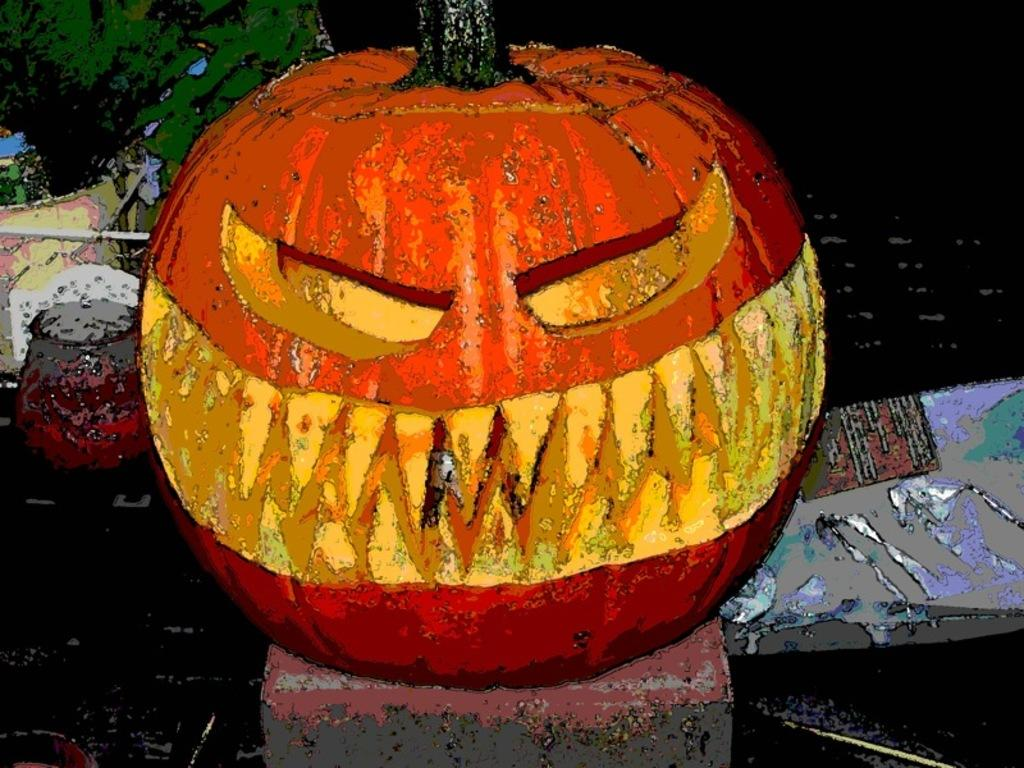What theme is depicted in the image? The image has a Halloween theme. Can you describe any other objects or elements in the image? Unfortunately, the provided facts only mention that there are many other objects in the image, but no specific details are given. How many tomatoes are on the shelf in the store depicted in the image? There is no store or shelf with tomatoes present in the image, as it has a Halloween theme. 